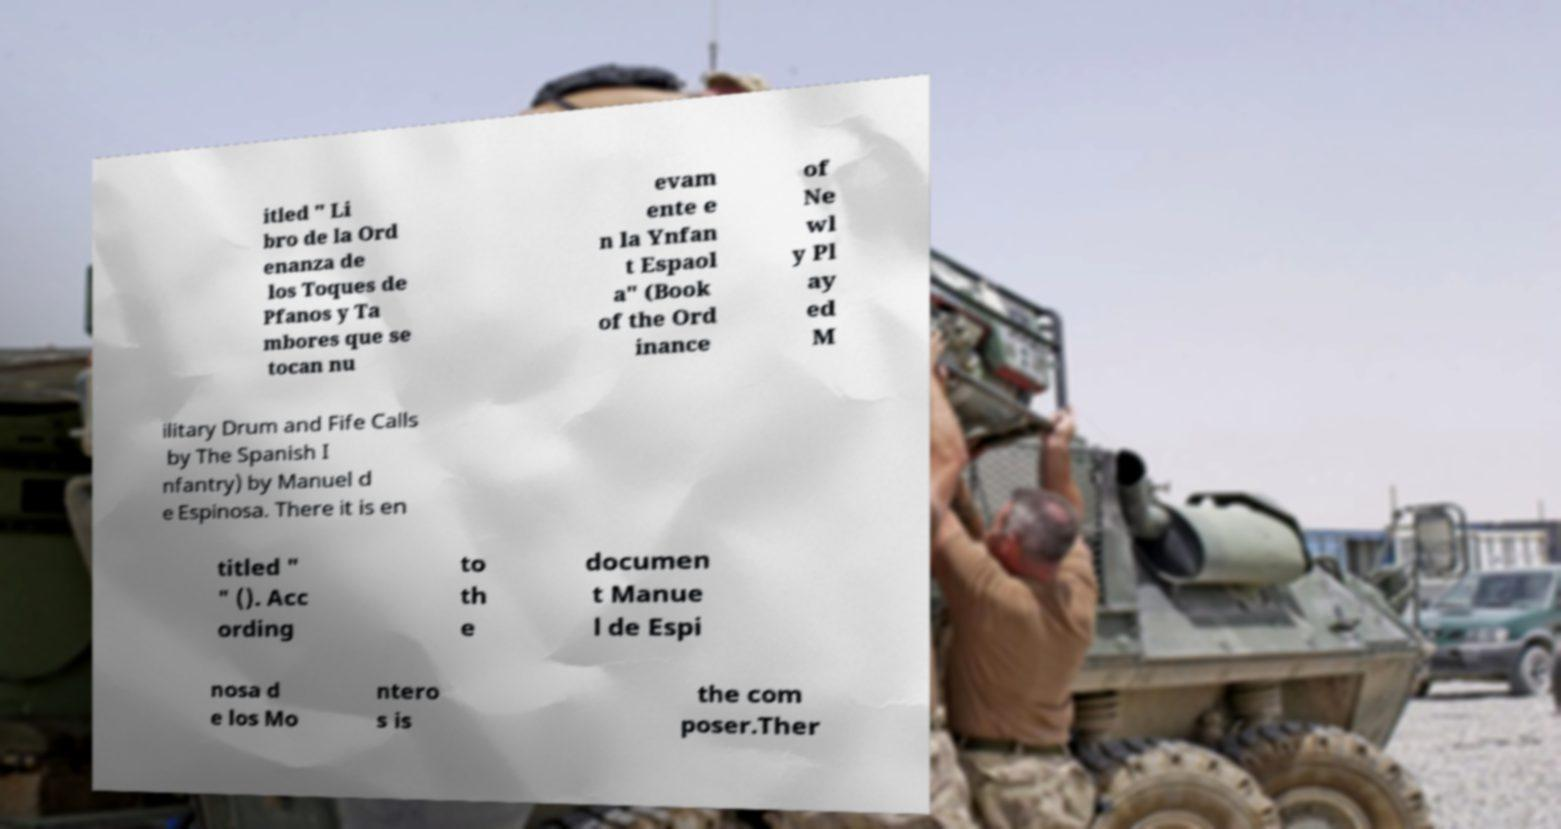There's text embedded in this image that I need extracted. Can you transcribe it verbatim? itled " Li bro de la Ord enanza de los Toques de Pfanos y Ta mbores que se tocan nu evam ente e n la Ynfan t Espaol a" (Book of the Ord inance of Ne wl y Pl ay ed M ilitary Drum and Fife Calls by The Spanish I nfantry) by Manuel d e Espinosa. There it is en titled " " (). Acc ording to th e documen t Manue l de Espi nosa d e los Mo ntero s is the com poser.Ther 